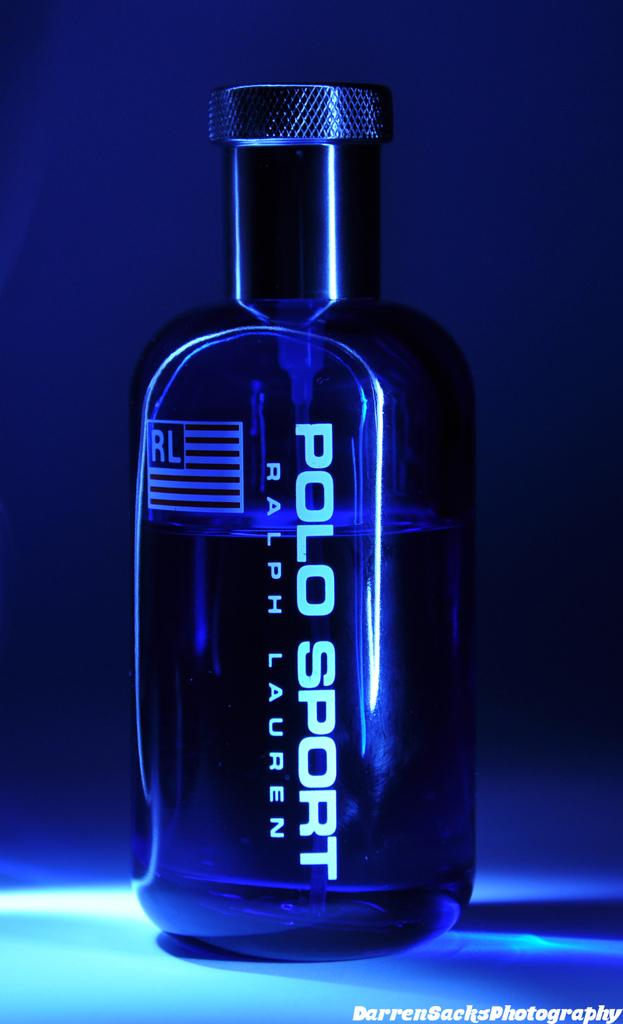<image>
Give a short and clear explanation of the subsequent image. A blue bottle of Polo Sport by Ralph Lauren. 